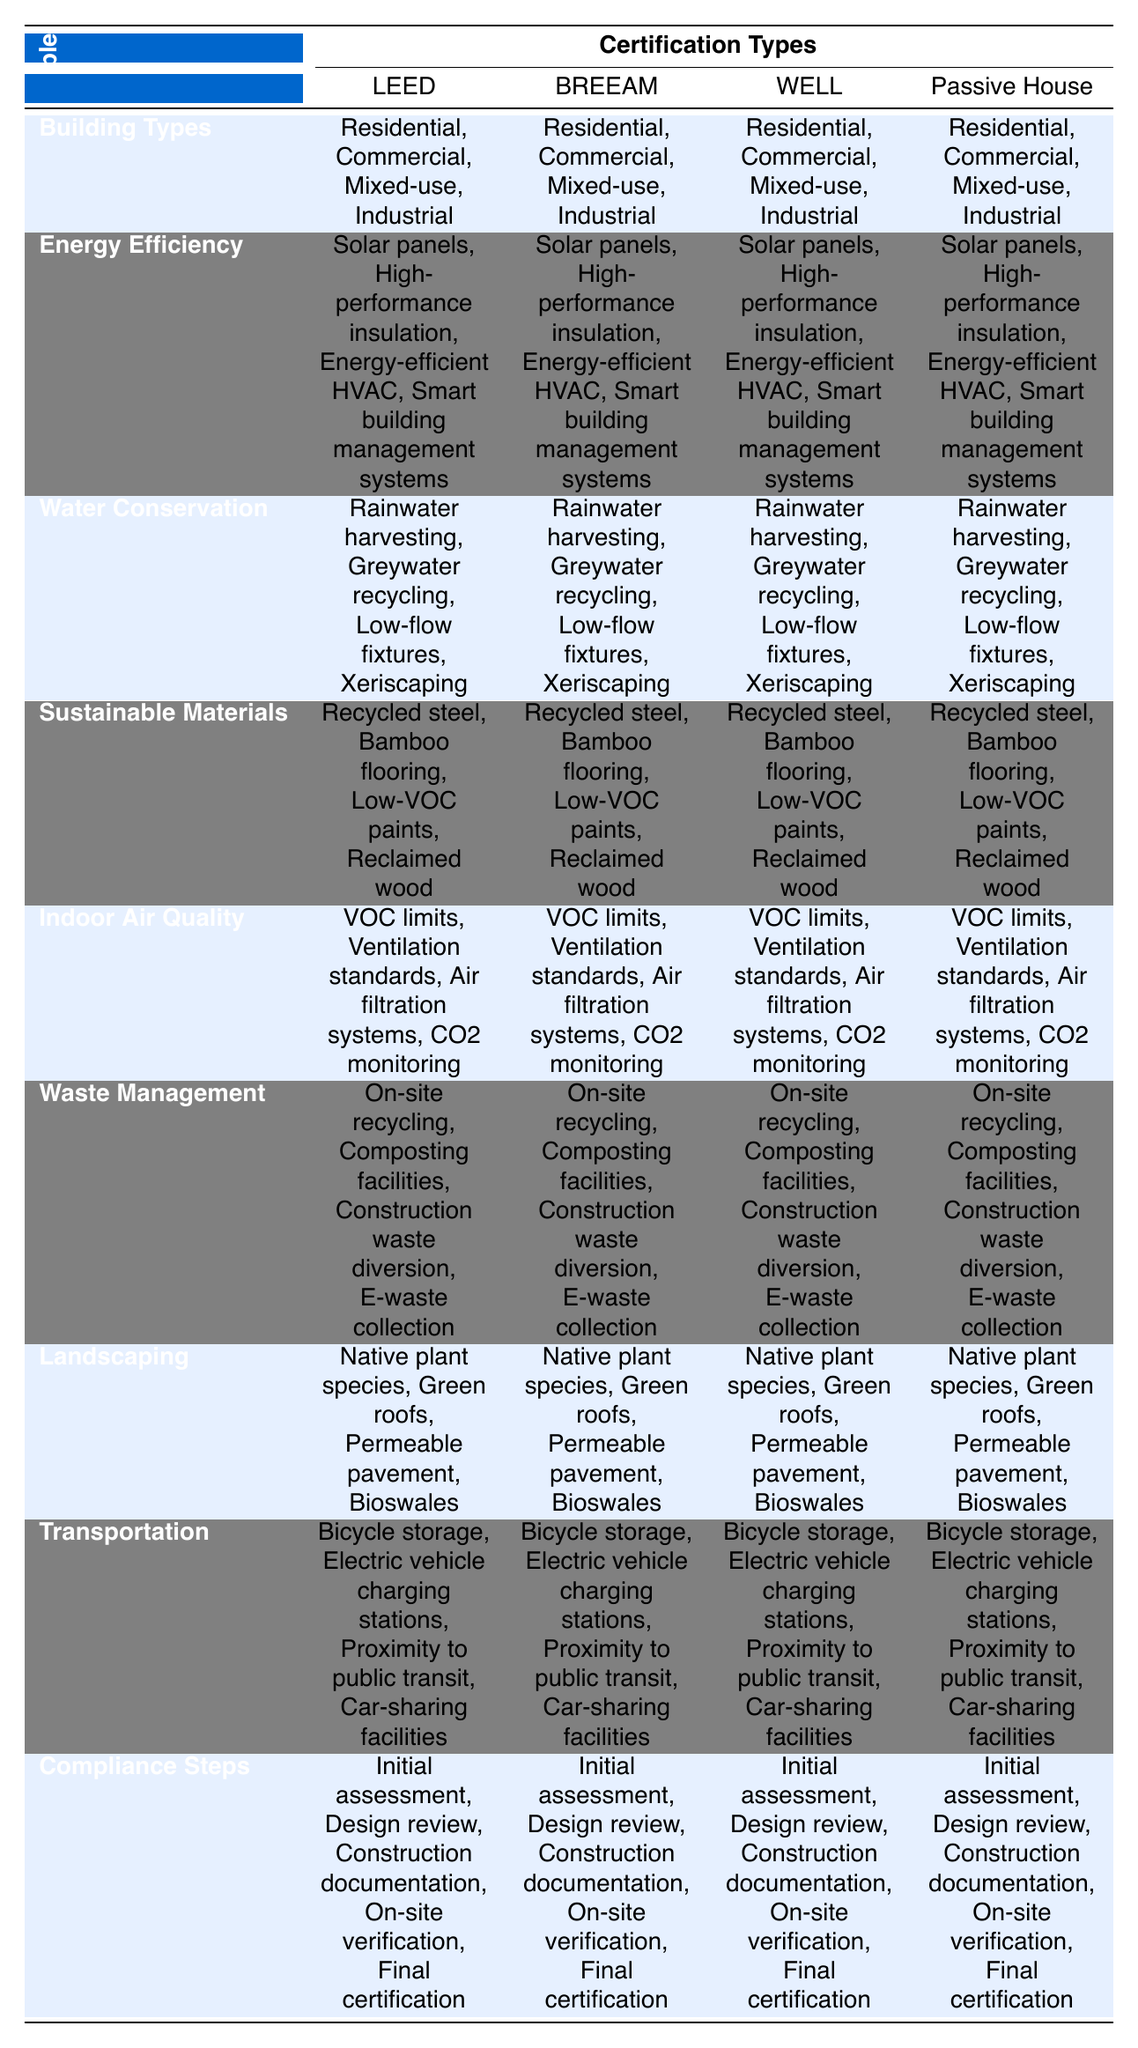What types of buildings can be certified under LEED? The table shows that under LEED certification, the eligible building types are Residential, Commercial, Mixed-use, and Industrial. This is directly referenced in the "Building Types" row under the LEED column.
Answer: Residential, Commercial, Mixed-use, Industrial Which energy efficiency measures are common across all certification types? By looking at the "Energy Efficiency" row, I can see that Solar panels, High-performance insulation, Energy-efficient HVAC, and Smart building management systems are listed under all certification types.
Answer: Solar panels, High-performance insulation, Energy-efficient HVAC, Smart building management systems Does Passive House certification require waste management practices? The table indicates that Passive House certification includes "On-site recycling," "Composting facilities," "Construction waste diversion," and "E-waste collection" in the "Waste Management" row, which confirms that it does require waste management practices.
Answer: Yes What is the total number of landscaping requirements listed for each certification type? The "Landscaping" row includes four requirements: Native plant species, Green roofs, Permeable pavement, and Bioswales for each certification type. Therefore, the total count is consistent across all types at four.
Answer: 4 Among the green building certifications, which ones require compliance steps to achieve certification? The table lists "Initial assessment," "Design review," "Construction documentation," "On-site verification," and "Final certification" under the "Compliance Steps" for each certification type. Since all types (LEED, BREEAM, WELL, Passive House) have this row filled, they all require these steps.
Answer: Yes, all require compliance steps What are the water conservation strategies listed for BREEAM certification? The second row under the BREEAM column lists the following water conservation strategies: Rainwater harvesting, Greywater recycling, Low-flow fixtures, and Xeriscaping. These details are directly pulled from the table.
Answer: Rainwater harvesting, Greywater recycling, Low-flow fixtures, Xeriscaping How many transportation considerations are presented for WELL certification? Looking at the "Transportation" row for the WELL certification, there are four considerations listed: Bicycle storage, Electric vehicle charging stations, Proximity to public transit, and Car-sharing facilities. Thus, the count is four.
Answer: 4 Which certification types include both water conservation strategies and landscaping requirements listed? By checking the rows for "Water Conservation" and "Landscaping" for each certification type, I observe that all certifications (LEED, BREEAM, WELL, Passive House) include strategies from both rows. Therefore, all certification types meet this criterion.
Answer: All certification types What percentage of the certifications offer sustainable materials as a requirement? The table shows that all four certification types (LEED, BREEAM, WELL, Passive House) have "Sustainable Materials" listed, so the percentage of certifications with this requirement is (4 out of 4) * 100 = 100%.
Answer: 100% 